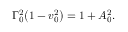<formula> <loc_0><loc_0><loc_500><loc_500>\Gamma _ { 0 } ^ { 2 } { \left ( 1 - v _ { 0 } ^ { 2 } \right ) } = 1 + A _ { 0 } ^ { 2 } .</formula> 